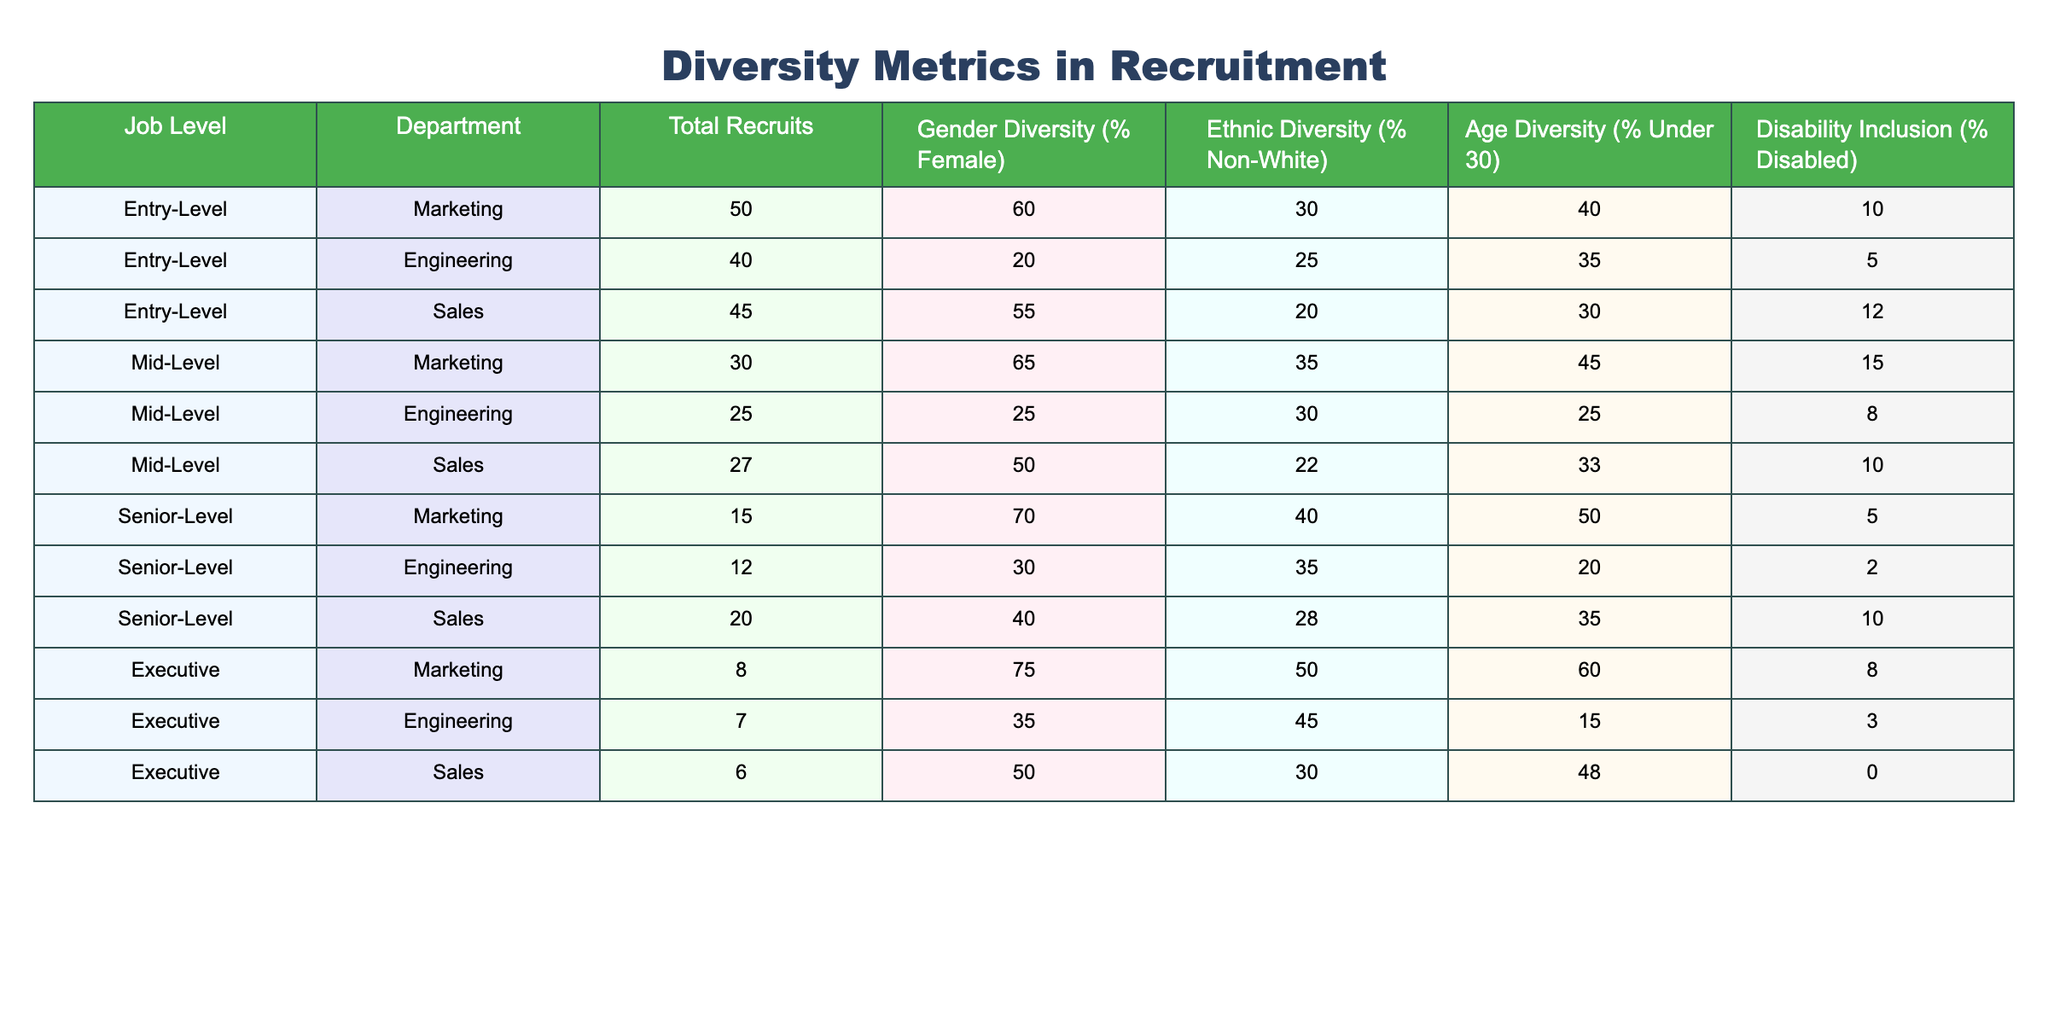What is the gender diversity percentage for entry-level recruits in the Marketing department? According to the table, the gender diversity percentage for entry-level recruits in Marketing is listed under "Gender Diversity (% Female)", which shows a value of 60%.
Answer: 60% Which department has the highest ethnic diversity in senior-level recruits? In the table, we compare the "Ethnic Diversity (% Non-White)" values for senior-level recruits across Marketing, Engineering, and Sales. Marketing has 40%, Engineering has 35%, and Sales has 28%. The highest is Marketing with 40%.
Answer: Marketing What is the total number of recruits at the mid-level across all departments? To find the total number of mid-level recruits, we sum the "Total Recruits" for the mid-level positions in Marketing (30), Engineering (25), and Sales (27). The total is 30 + 25 + 27 = 82.
Answer: 82 Is there any department in the entry-level category that has 50% or higher disability inclusion? From the table, we see the disability inclusion percentages for entry-level recruits: Marketing has 10%, Engineering has 5%, and Sales has 12%. Since none of these values reach 50%, the answer is no.
Answer: No What is the average gender diversity percentage across all senior-level recruits? First, we extract the gender diversity percentages for senior-level recruits: 70% for Marketing, 30% for Engineering, and 40% for Sales. We add these percentages: 70 + 30 + 40 = 140. There are 3 departments, so we divide by 3 to get the average: 140 / 3 ≈ 46.67%.
Answer: 46.67% Among all job levels and departments, which level shows the highest percentage of recruits under 30? Looking at the "Age Diversity (% Under 30)" rows in the table, we see that Marketing's senior level has 50%, and Mid-Level Marketing has 45%. The highest overall percentage for recruits under 30 is 60%, which belongs to the Executive level in Marketing.
Answer: Executive Marketing Which department has the lowest disability inclusion for senior-level recruits? We check the "Disability Inclusion (% Disabled)" values for senior-level positions: Marketing has 5%, Engineering has 2%, and Sales has 10%. The lowest percentage is Engineering at 2%.
Answer: Engineering How many more entry-level recruits does the Sales department have compared to the Engineering department? The table shows 45 entry-level recruits in Sales and 40 in Engineering. To find the difference, we subtract the Engineering recruits from the Sales recruits: 45 - 40 = 5.
Answer: 5 Are there more entry-level females in the Marketing department or mid-level females in the Engineering department? The table shows that entry-level females in Marketing percentage is 60% of 50 recruits, which is 30 females, while mid-level females in Engineering percentage is 25% of 25 recruits, which is 6. Since 30 > 6, entry-level females in Marketing are higher.
Answer: Marketing Entry-Level What is the total ethnic diversity percentage for all executive recruits? We look at the percentages for ethnic diversity in the executive level: Marketing 50%, Engineering 45%, and Sales 30%. We calculate the total: 50 + 45 + 30 = 125%. Therefore, the value is 125%.
Answer: 125% 